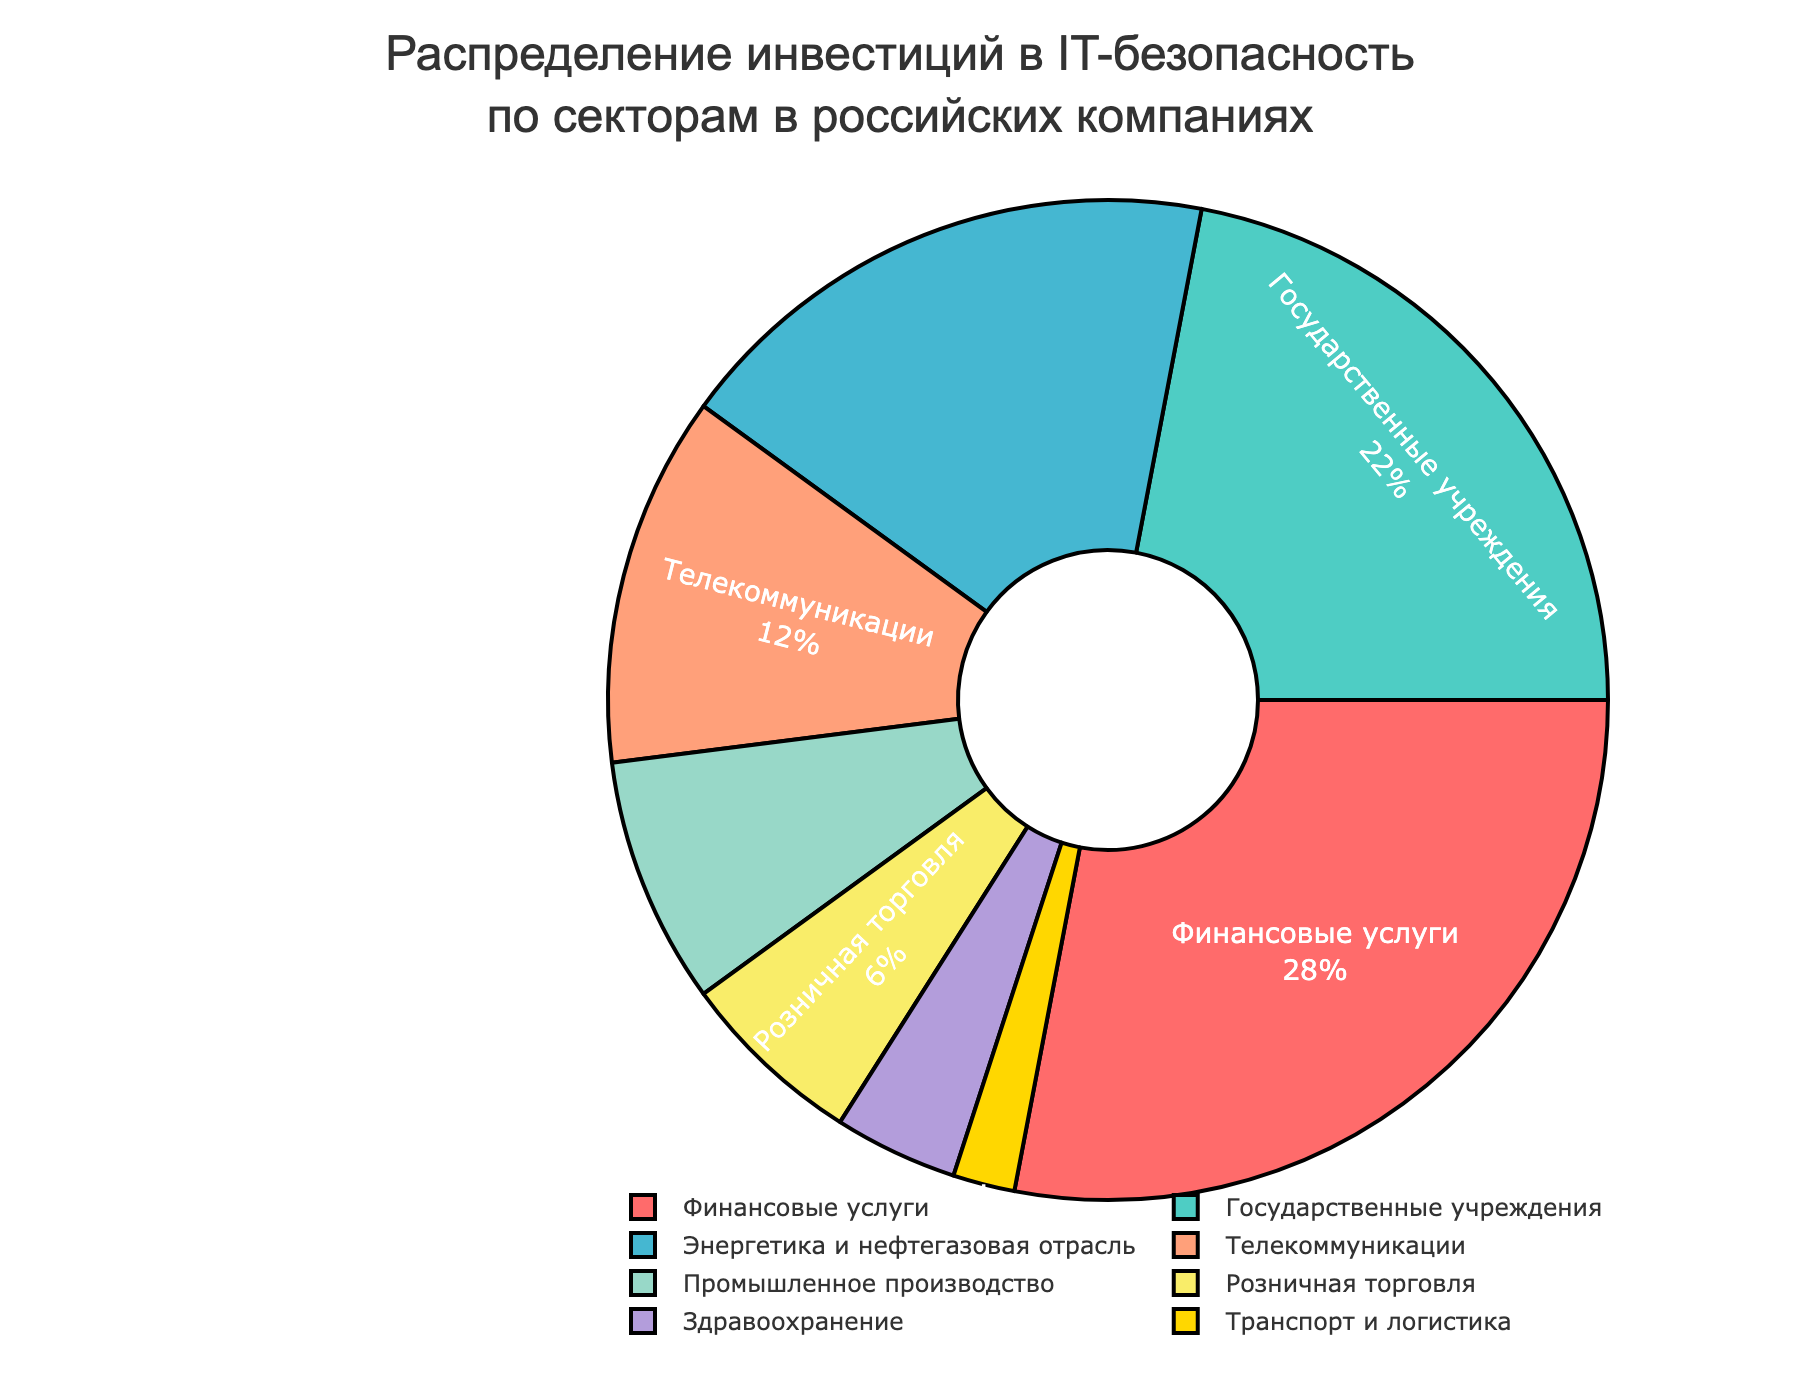Какая категория имеет наибольшую долю инвестиций в IT-безопасность? Наибольшую долю инвестиций имеет сектор с самой большой частью на диаграмме. В данном случае это "Финансовые услуги" с долей 28%.
Answer: Финансовые услуги Какова суммарная доля инвестиций в секторы энергетики и нефтегазовой отрасли и телекоммуникаций? Найдите долю инвестиций в "Энергетику и нефтегазовую отрасль" и "Телекоммуникации" и сложите эти значения. Это 18% и 12% соответственно. 18 + 12 = 30.
Answer: 30% Какой сектор имеет меньшее значение: транспорт и логистика или здравоохранение? Найдите значения для обоих секторов на графике. Транспорт и логистика имеют 2%, а здравоохранение - 4%. 2% меньше, чем 4%.
Answer: Транспорт и логистика Какой наименьший сектор по доле инвестиций и его процент? Определите сектор с наименьшей долей инвестиций по размеру сегмента на диаграмме. Это "Транспорт и логистика" с долей 2%.
Answer: Транспорт и логистика, 2% На сколько процентов доля инвестиций в государственные учреждения больше, чем доля инвестиций в промышленное производство? Найдите доли инвестиций для обоих секторов. Для государственных учреждений это 22%, для промышленного производства - 8%. Теперь вычтите: 22 - 8 = 14.
Answer: 14% Какие сектора имеют долю инвестиций меньше 10%? Определите сектора, доли которых на диаграмме меньше 10%. Сектора: Промышленное производство (8%), Розничная торговля (6%), Здравоохранение (4%), Транспорт и логистика (2%).
Answer: Промышленное производство, Розничная торговля, Здравоохранение, Транспорт и логистика Каково отношение доли инвестиций в финансовые услуги к доле инвестиций в телекоммуникации? Найдите доли инвестиций в финансовые услуги и телекоммуникации. Финансовые услуги 28%, телекоммуникации 12%. Отношение 28/12 = 2.33.
Answer: 2.33 Какие секторы имеют доли инвестиций, выраженные в красном и зеленом цветах на диаграмме? Определите цвета на диаграмме и соответствующие сектора. Красный цвет - Финансовые услуги. Зеленый - Государственные учреждения.
Answer: Финансовые услуги, Государственные учреждения 